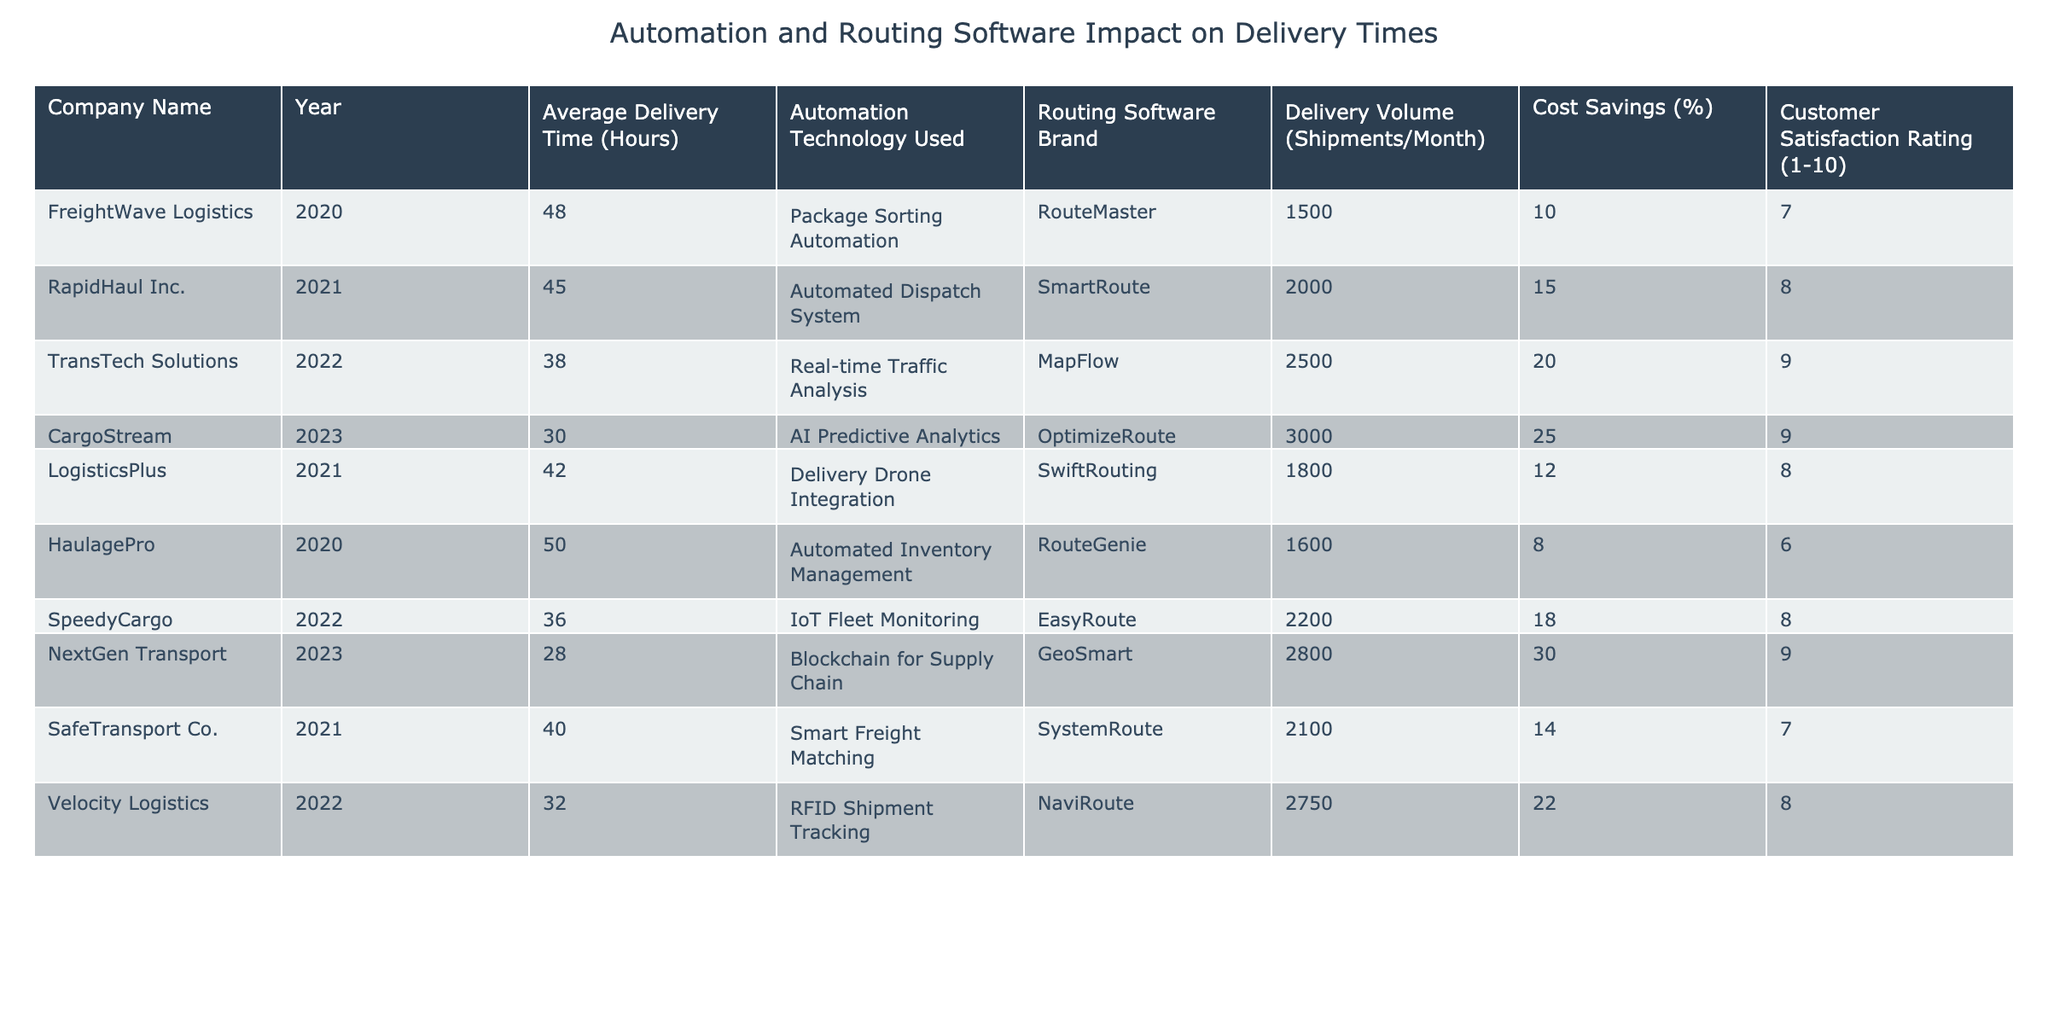What's the average delivery time for companies using AI Predictive Analytics? The only company listed that uses AI Predictive Analytics is CargoStream. Their average delivery time is 30 hours.
Answer: 30 hours Which company had the highest customer satisfaction rating? Looking through the table, CargoStream and NextGen Transport both have a customer satisfaction rating of 9, which is the highest in the table.
Answer: CargoStream and NextGen Transport What is the total delivery volume for the companies that implemented automated dispatch systems? The only company with an automated dispatch system is RapidHaul Inc., which has a delivery volume of 2000 shipments/month. Therefore, the total delivery volume is 2000.
Answer: 2000 shipments/month Did any company achieve a customer satisfaction rating of 10? No company reported a customer satisfaction rating of 10, as the highest rating in the table is 9 shared by CargoStream and NextGen Transport.
Answer: No Which company's average delivery time improved the most from the previous year? Compare the average delivery times for the years available. CargoStream's average delivery time improved by 8 hours from LogisticsPlus in 2021 to 30 hours in 2023, which is the most significant improvement.
Answer: CargoStream What is the average cost savings percentage among the companies in the table? First, we sum the cost savings percentages: 10 + 15 + 20 + 25 + 12 + 8 + 18 + 30 + 14 + 22 =  174. There are 10 companies, so the average cost savings percentage is 174/10 = 17.4%.
Answer: 17.4% Which year had the least average delivery time recorded in the table? The company with the least average delivery time is NextGen Transport with an average of 28 hours in 2023.
Answer: 2023 What percentage decrease in average delivery time did SpeedyCargo achieve from 2022 to 2023? SpeedyCargo's average delivery time dropped from 36 hours (2022) to 28 hours (2023). The decrease is 36 - 28 = 8 hours. The percentage decrease is (8/36) * 100 = 22.22%.
Answer: 22.22% Which routing software brand had the largest number of shipments delivered by its associated company? The company with the highest delivery volume is CargoStream, which utilizes OptimizeRoute, delivering 3000 shipments per month.
Answer: OptimizeRoute 